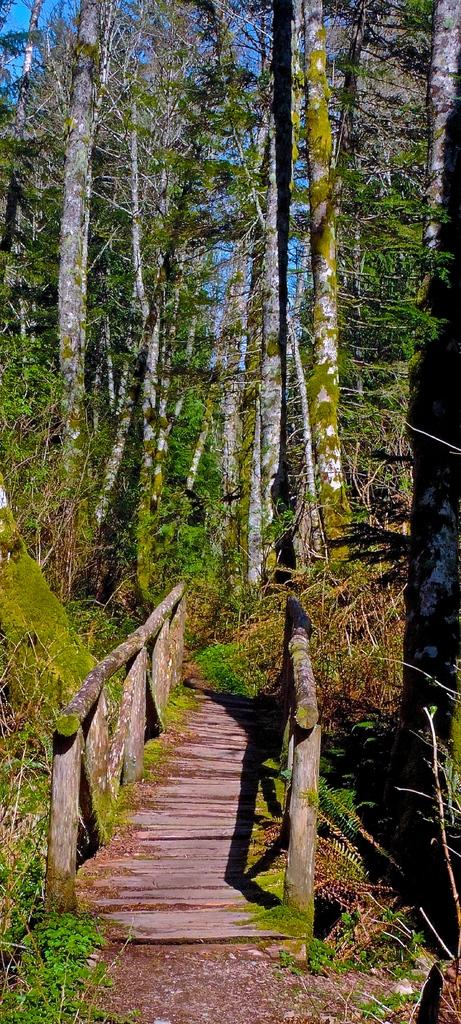What type of structure is present in the image? There is a wooden bridge in the image. What can be seen in the background of the image? There are trees and the sky visible in the background of the image. What type of bread can be seen floating on the lake in the image? There is no lake or bread present in the image; it features a wooden bridge and trees in the background. 